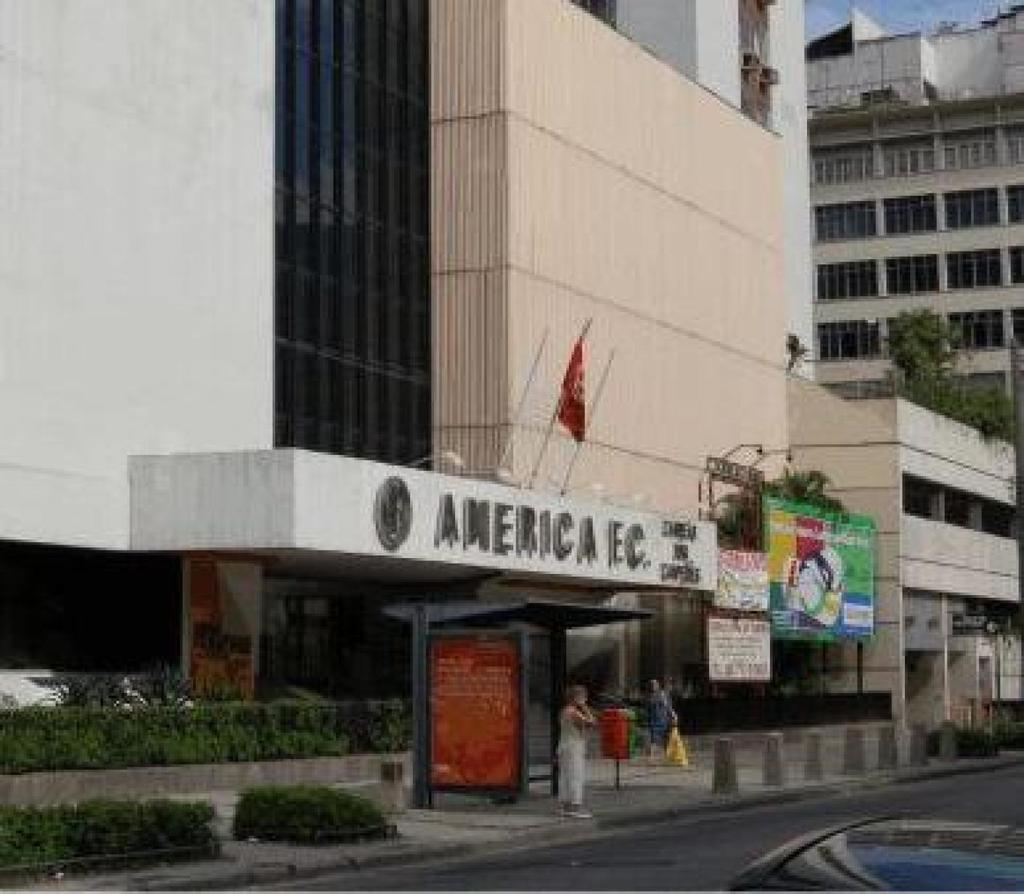What type of structures are visible in the image? There are buildings with text in the image. Who or what else can be seen in the image? There are people in the image. What is located in the foreground of the image? Small plants are present in the foreground of the image. What is at the bottom of the image? There is a road at the bottom of the image. What is visible at the top of the image? The sky is visible at the top of the image. How many chickens are perched on the chin of the person in the image? There are no chickens or people with visible chins present in the image. What type of snake is slithering across the road in the image? There are no snakes visible in the image; it features buildings, people, small plants, a road, and the sky. 